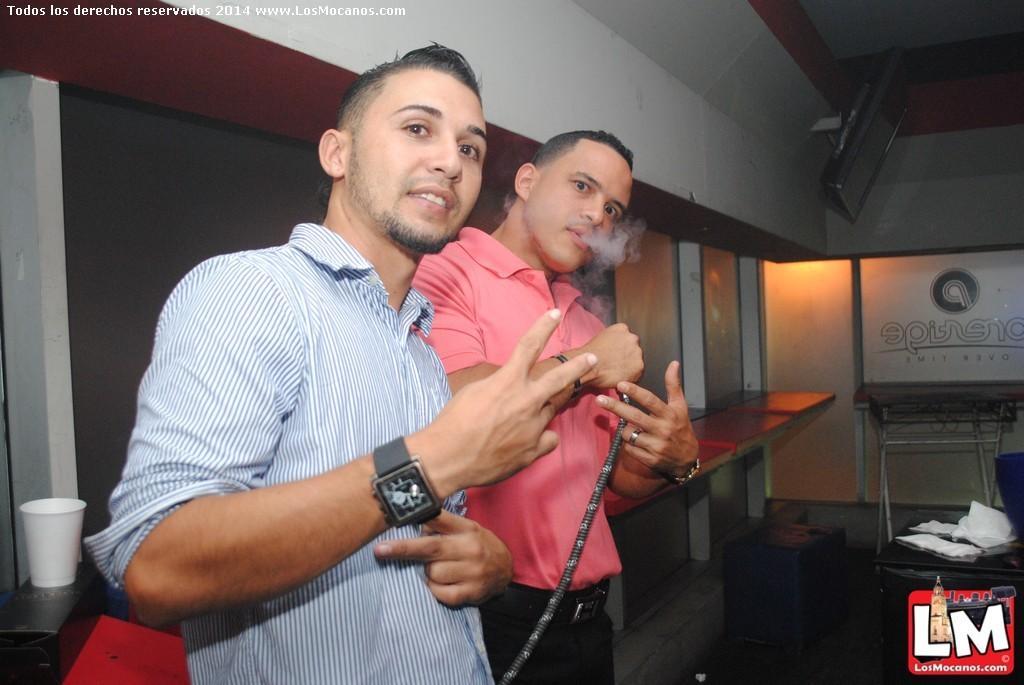Could you give a brief overview of what you see in this image? In the center of the image we can see two persons are standing and they are in different costumes. Among them, we can see one person is smiling and the other person is holding a hookah pipe and he is smoking. At the bottom right side of the image, there is a logo. In the background there is a wall, tables, one glass, one banner, papers, one monitor and a few other objects. At the top left side of the image, we can see some text. 